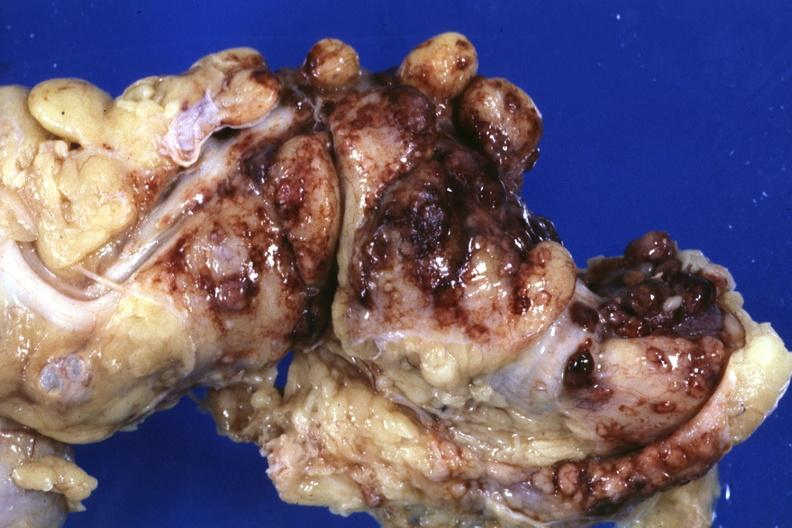what does this image show?
Answer the question using a single word or phrase. Fixed tissue 